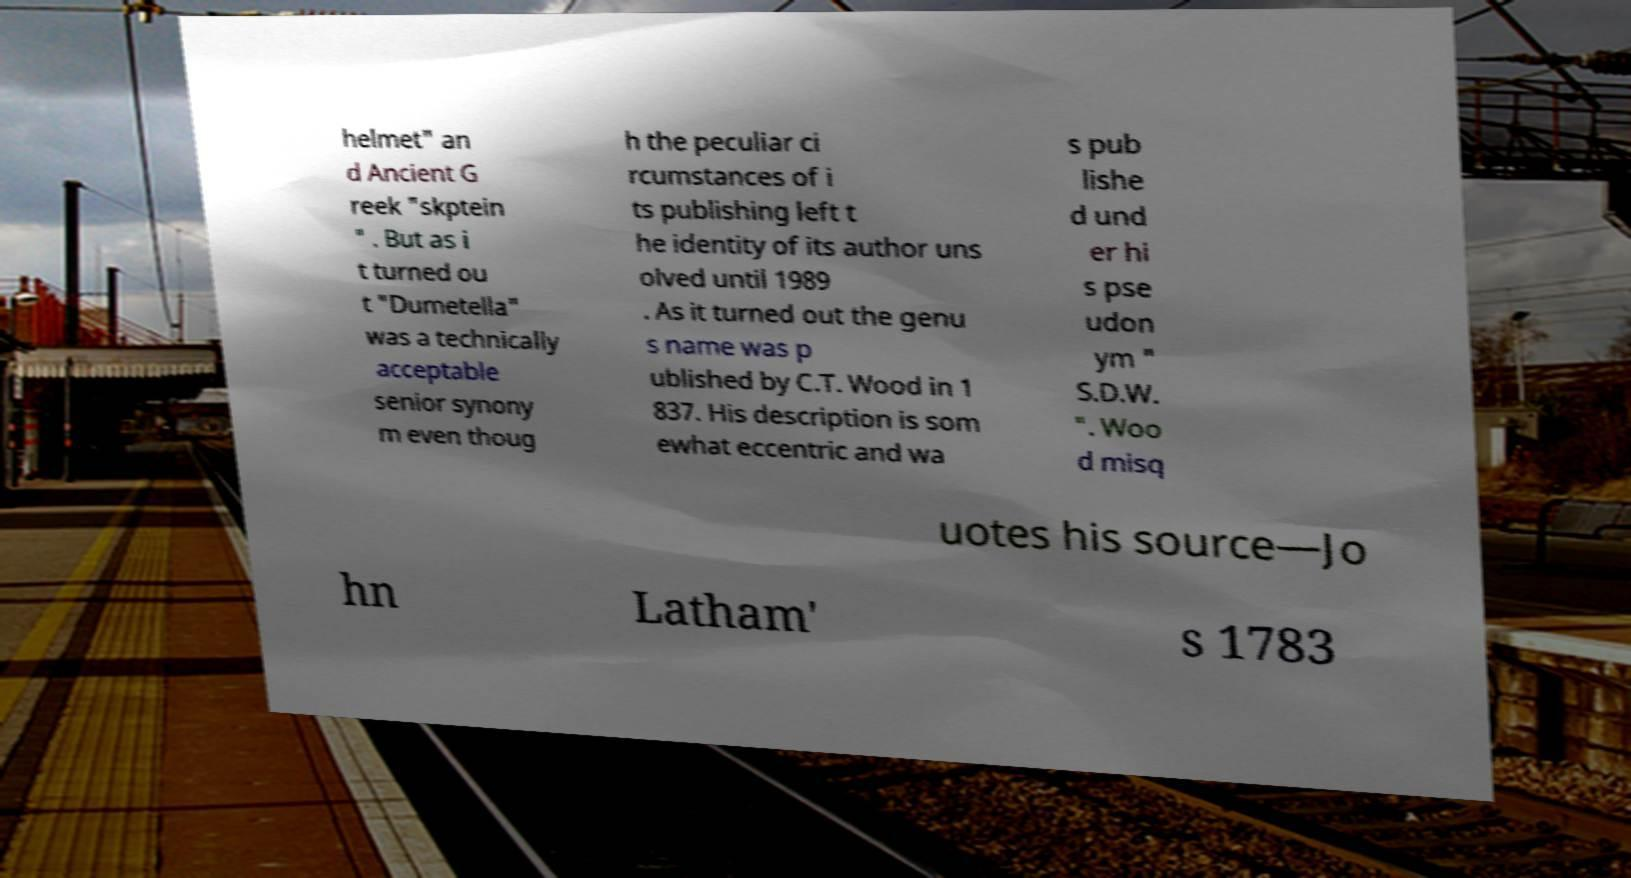For documentation purposes, I need the text within this image transcribed. Could you provide that? helmet" an d Ancient G reek "skptein " . But as i t turned ou t "Dumetella" was a technically acceptable senior synony m even thoug h the peculiar ci rcumstances of i ts publishing left t he identity of its author uns olved until 1989 . As it turned out the genu s name was p ublished by C.T. Wood in 1 837. His description is som ewhat eccentric and wa s pub lishe d und er hi s pse udon ym " S.D.W. ". Woo d misq uotes his source—Jo hn Latham' s 1783 